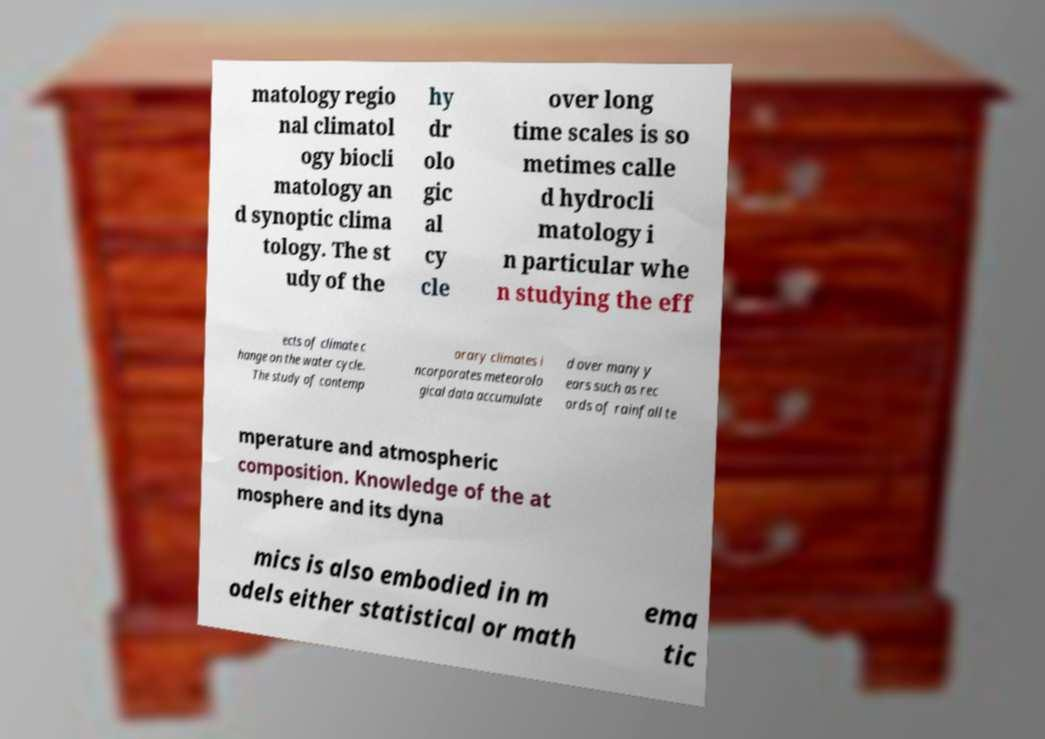I need the written content from this picture converted into text. Can you do that? matology regio nal climatol ogy biocli matology an d synoptic clima tology. The st udy of the hy dr olo gic al cy cle over long time scales is so metimes calle d hydrocli matology i n particular whe n studying the eff ects of climate c hange on the water cycle. The study of contemp orary climates i ncorporates meteorolo gical data accumulate d over many y ears such as rec ords of rainfall te mperature and atmospheric composition. Knowledge of the at mosphere and its dyna mics is also embodied in m odels either statistical or math ema tic 